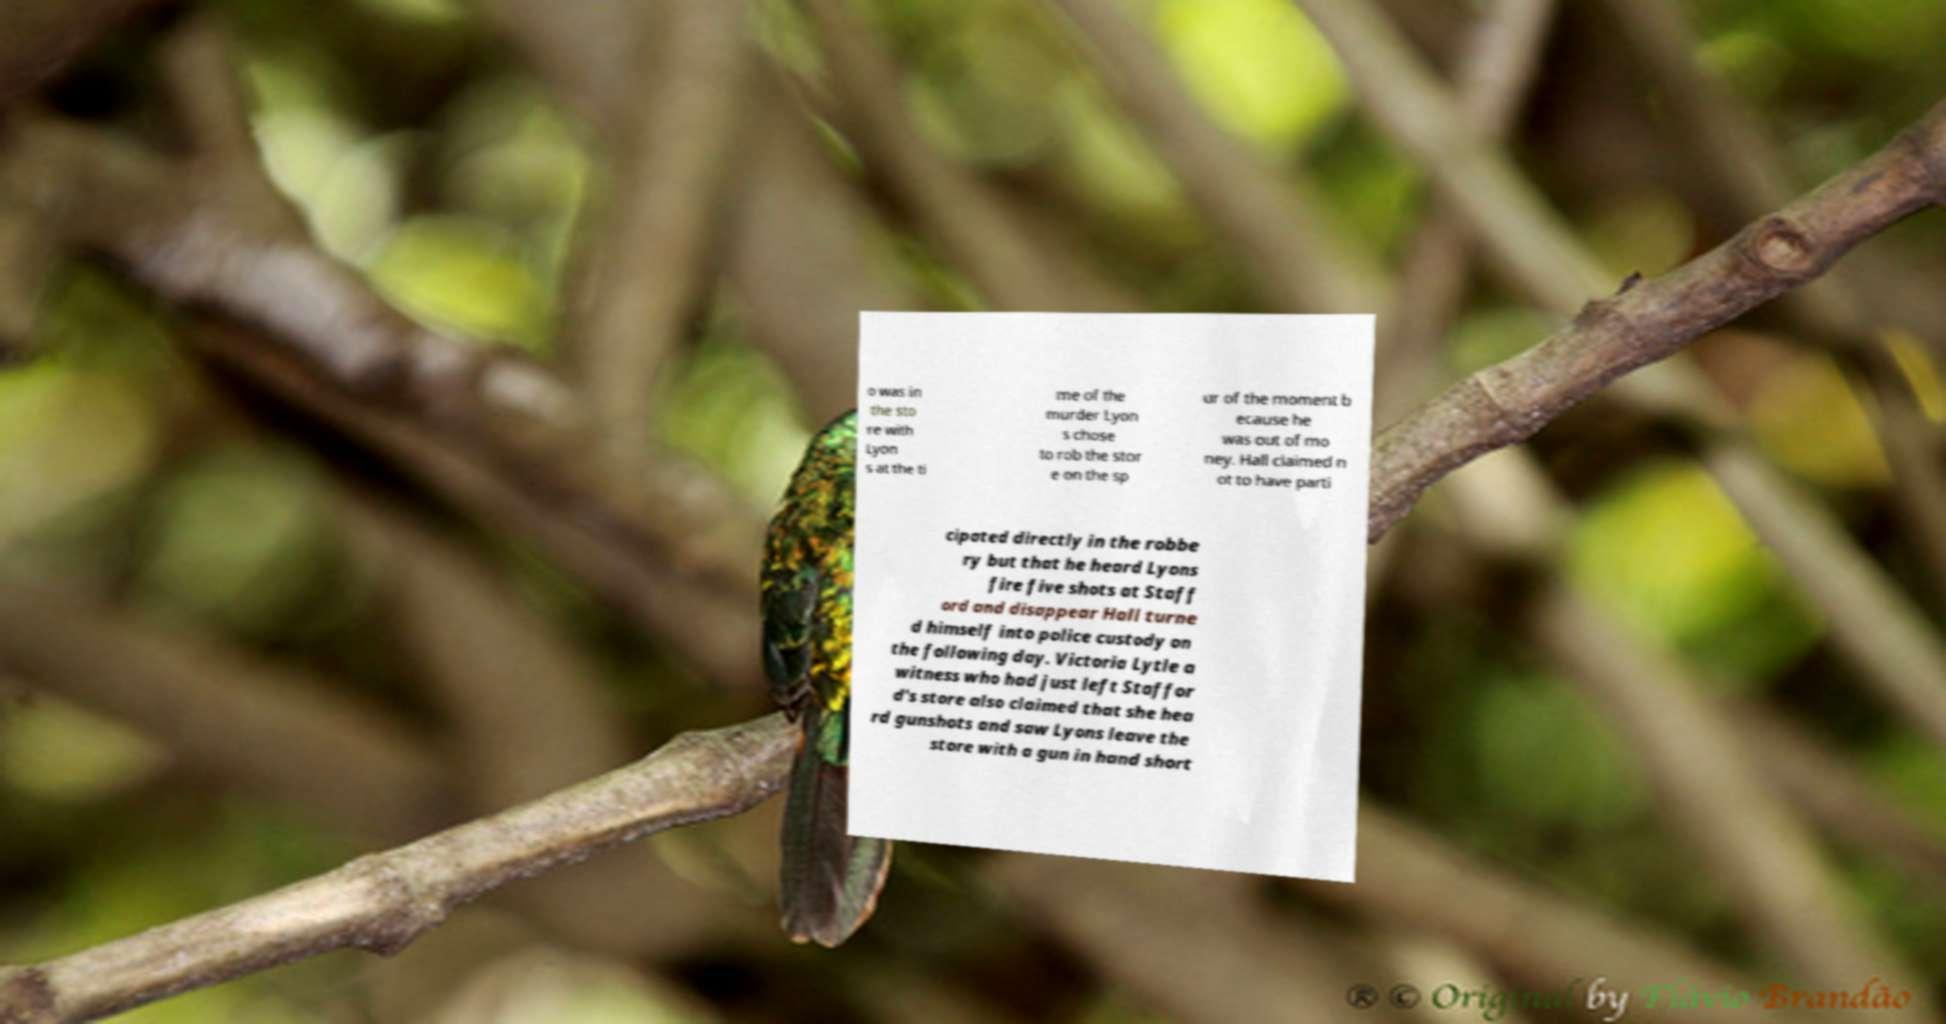Can you accurately transcribe the text from the provided image for me? o was in the sto re with Lyon s at the ti me of the murder Lyon s chose to rob the stor e on the sp ur of the moment b ecause he was out of mo ney. Hall claimed n ot to have parti cipated directly in the robbe ry but that he heard Lyons fire five shots at Staff ord and disappear Hall turne d himself into police custody on the following day. Victoria Lytle a witness who had just left Staffor d's store also claimed that she hea rd gunshots and saw Lyons leave the store with a gun in hand short 